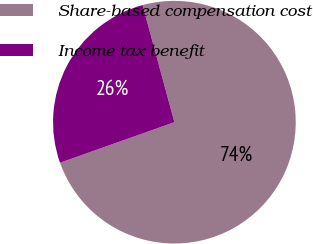Convert chart. <chart><loc_0><loc_0><loc_500><loc_500><pie_chart><fcel>Share-based compensation cost<fcel>Income tax benefit<nl><fcel>73.8%<fcel>26.2%<nl></chart> 